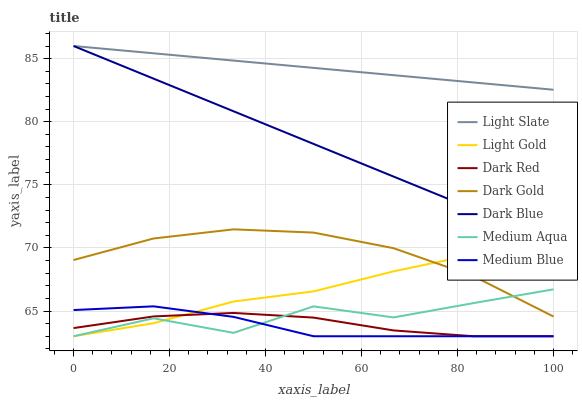Does Medium Blue have the minimum area under the curve?
Answer yes or no. Yes. Does Light Slate have the maximum area under the curve?
Answer yes or no. Yes. Does Dark Red have the minimum area under the curve?
Answer yes or no. No. Does Dark Red have the maximum area under the curve?
Answer yes or no. No. Is Dark Blue the smoothest?
Answer yes or no. Yes. Is Medium Aqua the roughest?
Answer yes or no. Yes. Is Light Slate the smoothest?
Answer yes or no. No. Is Light Slate the roughest?
Answer yes or no. No. Does Light Slate have the lowest value?
Answer yes or no. No. Does Dark Blue have the highest value?
Answer yes or no. Yes. Does Dark Red have the highest value?
Answer yes or no. No. Is Dark Red less than Dark Blue?
Answer yes or no. Yes. Is Light Slate greater than Medium Aqua?
Answer yes or no. Yes. Does Medium Aqua intersect Light Gold?
Answer yes or no. Yes. Is Medium Aqua less than Light Gold?
Answer yes or no. No. Is Medium Aqua greater than Light Gold?
Answer yes or no. No. Does Dark Red intersect Dark Blue?
Answer yes or no. No. 